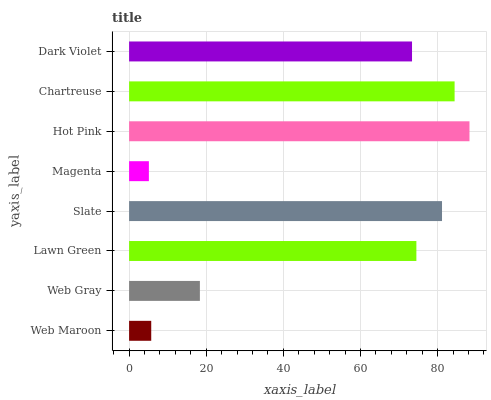Is Magenta the minimum?
Answer yes or no. Yes. Is Hot Pink the maximum?
Answer yes or no. Yes. Is Web Gray the minimum?
Answer yes or no. No. Is Web Gray the maximum?
Answer yes or no. No. Is Web Gray greater than Web Maroon?
Answer yes or no. Yes. Is Web Maroon less than Web Gray?
Answer yes or no. Yes. Is Web Maroon greater than Web Gray?
Answer yes or no. No. Is Web Gray less than Web Maroon?
Answer yes or no. No. Is Lawn Green the high median?
Answer yes or no. Yes. Is Dark Violet the low median?
Answer yes or no. Yes. Is Magenta the high median?
Answer yes or no. No. Is Chartreuse the low median?
Answer yes or no. No. 